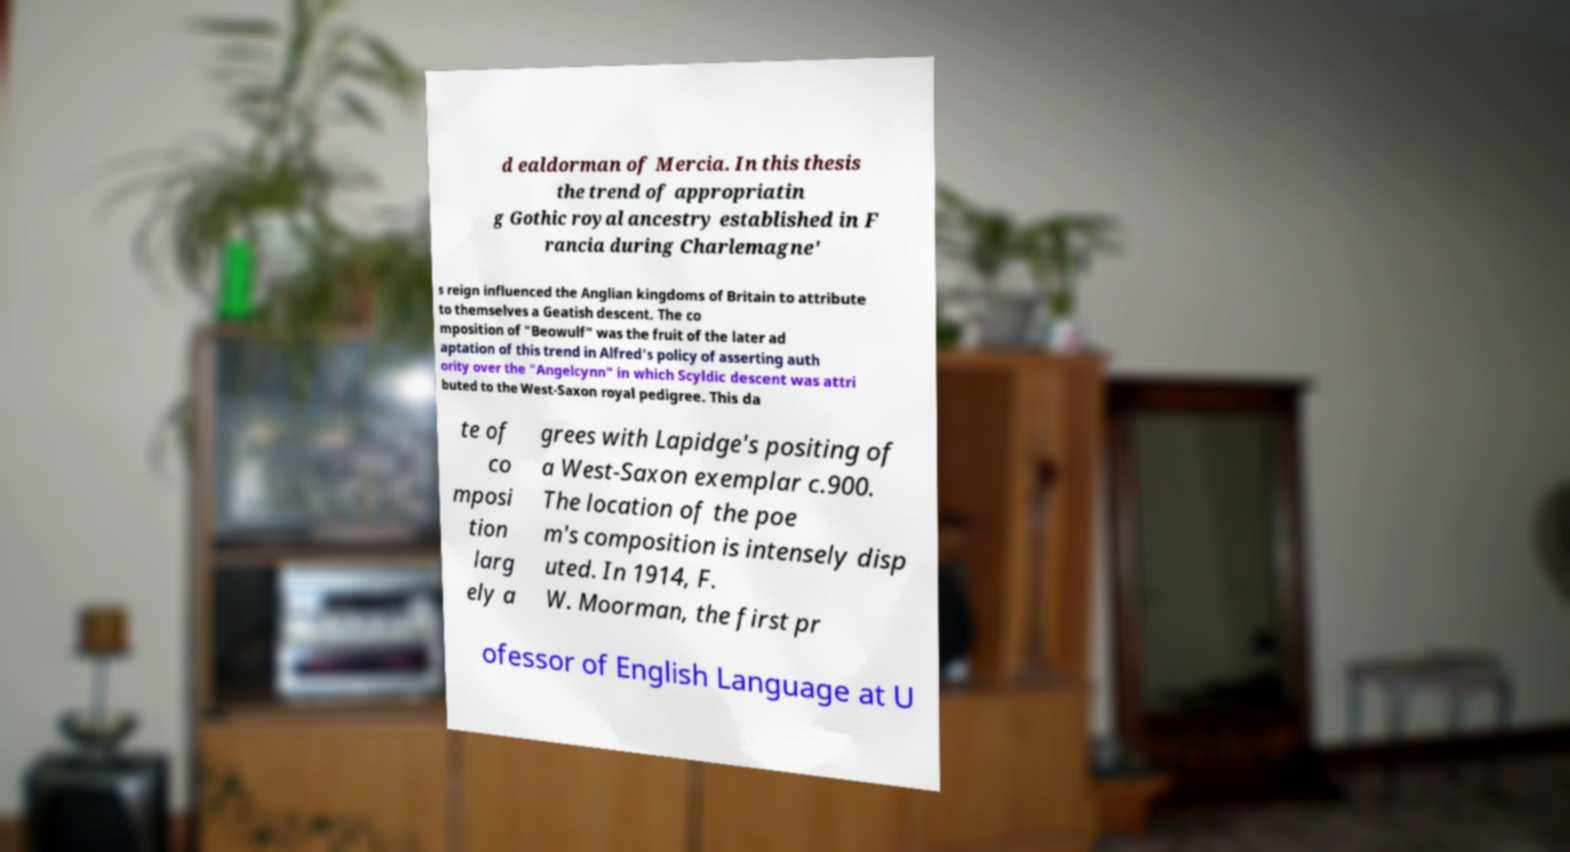What messages or text are displayed in this image? I need them in a readable, typed format. d ealdorman of Mercia. In this thesis the trend of appropriatin g Gothic royal ancestry established in F rancia during Charlemagne' s reign influenced the Anglian kingdoms of Britain to attribute to themselves a Geatish descent. The co mposition of "Beowulf" was the fruit of the later ad aptation of this trend in Alfred's policy of asserting auth ority over the "Angelcynn" in which Scyldic descent was attri buted to the West-Saxon royal pedigree. This da te of co mposi tion larg ely a grees with Lapidge's positing of a West-Saxon exemplar c.900. The location of the poe m's composition is intensely disp uted. In 1914, F. W. Moorman, the first pr ofessor of English Language at U 